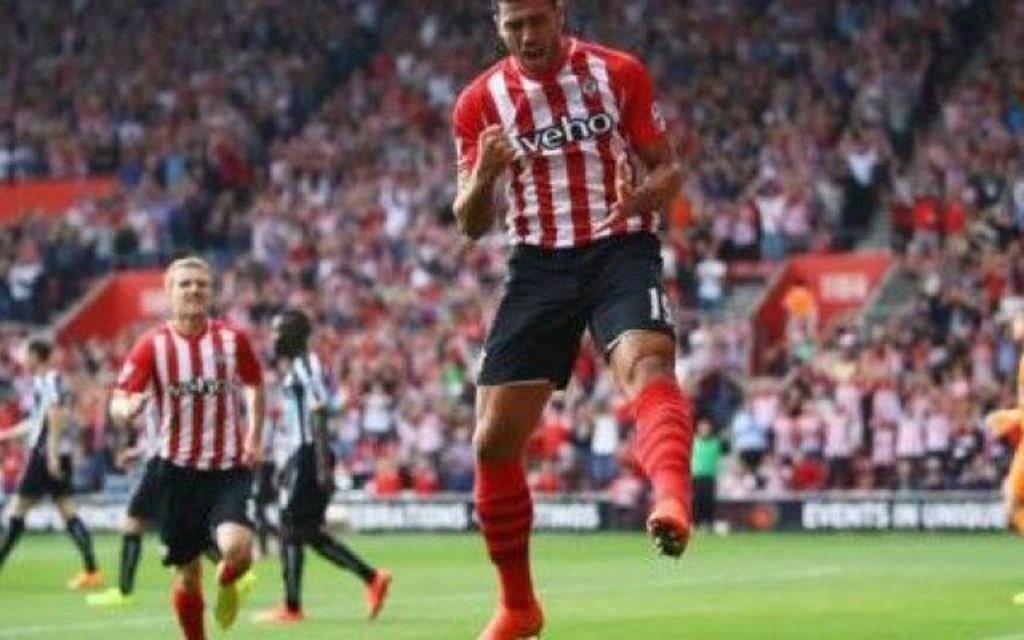What is happening in the foreground of the image? There are people on the ground in the image. What can be seen in the background of the image? There is a crowd and boards visible in the background of the image. What type of turkey can be seen in the image? There is no turkey present in the image. Is there a church visible in the image? There is no church present in the image. 